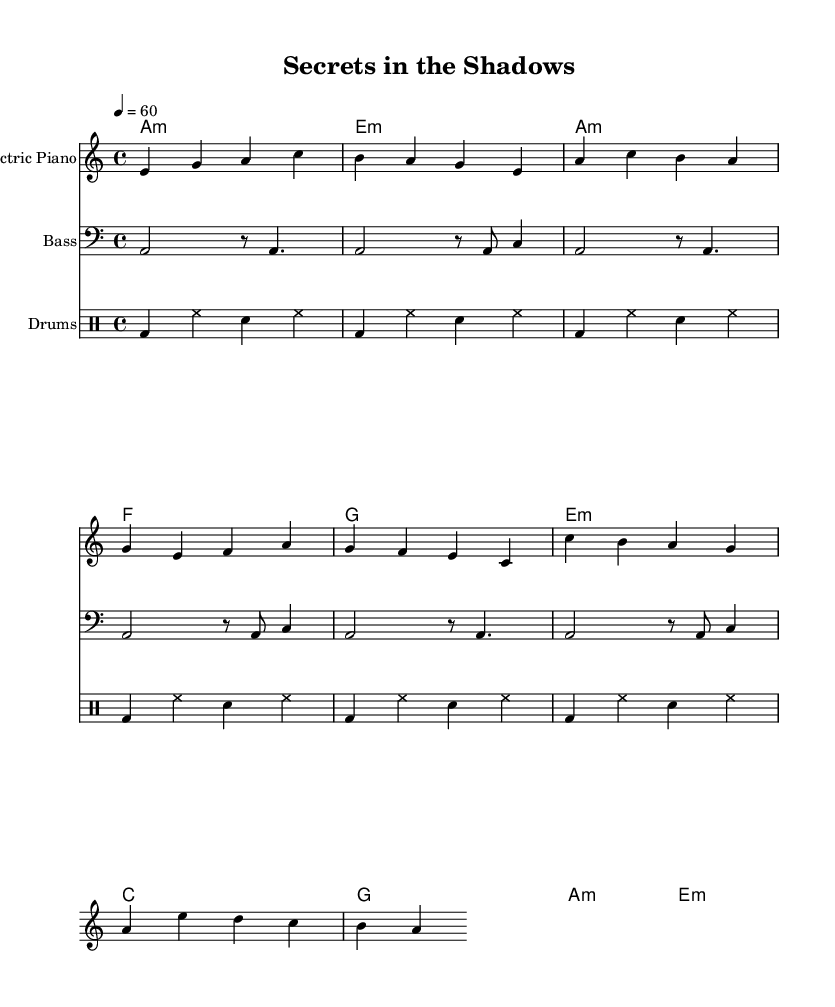What is the key signature of this music? The key signature is indicated by the key signature symbol, which shows that there are no sharps or flats present, making it A minor.
Answer: A minor What is the time signature of this music? The time signature is found at the beginning of the sheet music, where it is written as 4/4, indicating that there are four beats in each measure.
Answer: 4/4 What is the tempo marking? The tempo marking is indicated at the beginning of the music, stating a metronome marking of 60 beats per minute, which guides the musician on how fast to play.
Answer: 60 How many measures are in the verse section? By counting the measures listed in the verse portion of the sheet music, we find that there are four measures in this section.
Answer: 4 What is the dominant chord used in the chorus? The dominant chord in the key of A minor is E major, as identified in the chord progression indicated in the chorus section of the music.
Answer: E major What is the primary instrument playing the melody? The electric piano is designated at the top of the staff, and it is the instrument specified to perform the main melody of the piece.
Answer: Electric Piano What rhythmic pattern is used in the drums part? The drums part shows a consistent alternation of bass drum and snare hits throughout the section, which is a common rhythmic motif in rhythm and blues music.
Answer: Alternating bass and snare 